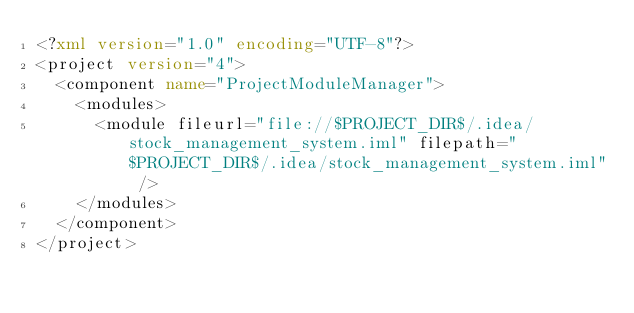<code> <loc_0><loc_0><loc_500><loc_500><_XML_><?xml version="1.0" encoding="UTF-8"?>
<project version="4">
  <component name="ProjectModuleManager">
    <modules>
      <module fileurl="file://$PROJECT_DIR$/.idea/stock_management_system.iml" filepath="$PROJECT_DIR$/.idea/stock_management_system.iml" />
    </modules>
  </component>
</project></code> 